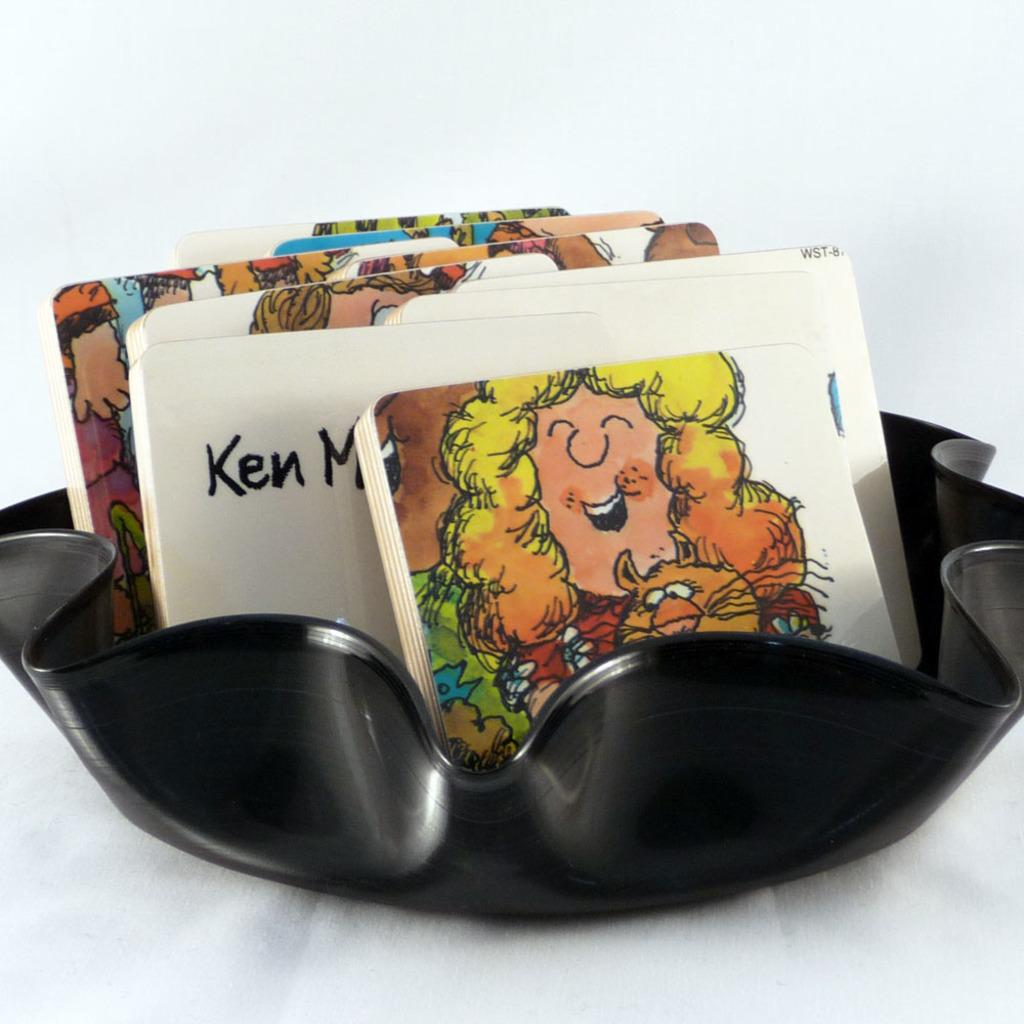What objects are present in the image? There are cards in the image. What can be observed on the cards? The cards have images on them. What is the color of the bowl in which the cards are placed? The black color bowl is placed on a white color surface. How many colors are mentioned in the description of the bowl and surface? Two colors are mentioned: black for the bowl and white for the surface. Are there any police officers visible in the image? No, there are no police officers present in the image. Can you tell me how many snakes are slithering on the cards in the image? There are no snakes present in the image; the cards have images on them, but no snakes are mentioned. 